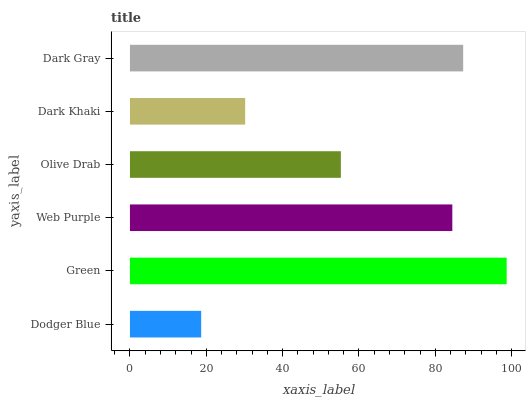Is Dodger Blue the minimum?
Answer yes or no. Yes. Is Green the maximum?
Answer yes or no. Yes. Is Web Purple the minimum?
Answer yes or no. No. Is Web Purple the maximum?
Answer yes or no. No. Is Green greater than Web Purple?
Answer yes or no. Yes. Is Web Purple less than Green?
Answer yes or no. Yes. Is Web Purple greater than Green?
Answer yes or no. No. Is Green less than Web Purple?
Answer yes or no. No. Is Web Purple the high median?
Answer yes or no. Yes. Is Olive Drab the low median?
Answer yes or no. Yes. Is Dodger Blue the high median?
Answer yes or no. No. Is Dark Gray the low median?
Answer yes or no. No. 